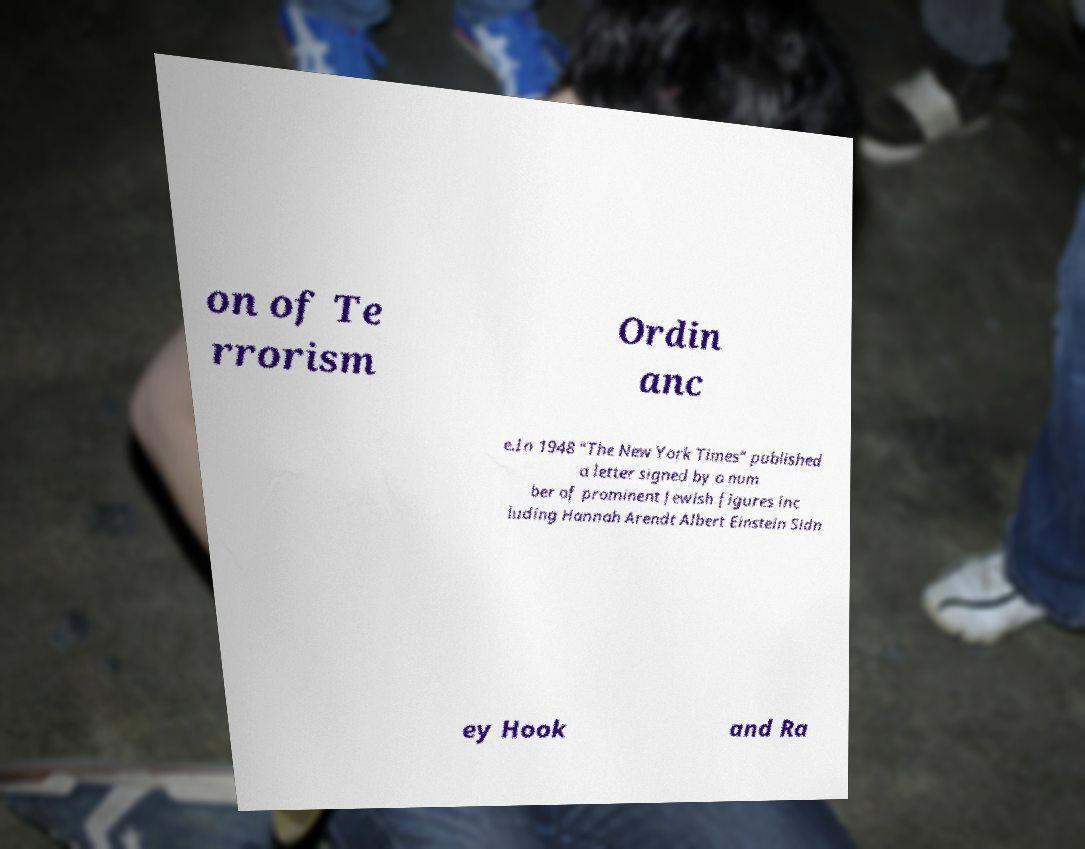There's text embedded in this image that I need extracted. Can you transcribe it verbatim? on of Te rrorism Ordin anc e.In 1948 "The New York Times" published a letter signed by a num ber of prominent Jewish figures inc luding Hannah Arendt Albert Einstein Sidn ey Hook and Ra 